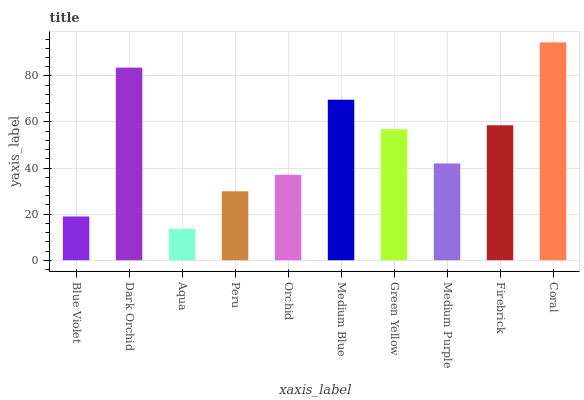Is Dark Orchid the minimum?
Answer yes or no. No. Is Dark Orchid the maximum?
Answer yes or no. No. Is Dark Orchid greater than Blue Violet?
Answer yes or no. Yes. Is Blue Violet less than Dark Orchid?
Answer yes or no. Yes. Is Blue Violet greater than Dark Orchid?
Answer yes or no. No. Is Dark Orchid less than Blue Violet?
Answer yes or no. No. Is Green Yellow the high median?
Answer yes or no. Yes. Is Medium Purple the low median?
Answer yes or no. Yes. Is Dark Orchid the high median?
Answer yes or no. No. Is Orchid the low median?
Answer yes or no. No. 